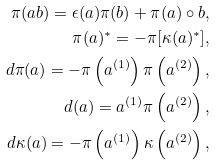<formula> <loc_0><loc_0><loc_500><loc_500>\pi ( a b ) = \epsilon ( a ) \pi ( b ) + \pi ( a ) \circ b , \\ \pi ( a ) ^ { * } = - \pi [ \kappa ( a ) ^ { * } ] , \\ d \pi ( a ) = - \pi \left ( a ^ { ( 1 ) } \right ) \pi \left ( a ^ { ( 2 ) } \right ) , \\ d ( a ) = a ^ { ( 1 ) } \pi \left ( a ^ { ( 2 ) } \right ) , \\ d \kappa ( a ) = - \pi \left ( a ^ { ( 1 ) } \right ) \kappa \left ( a ^ { ( 2 ) } \right ) ,</formula> 